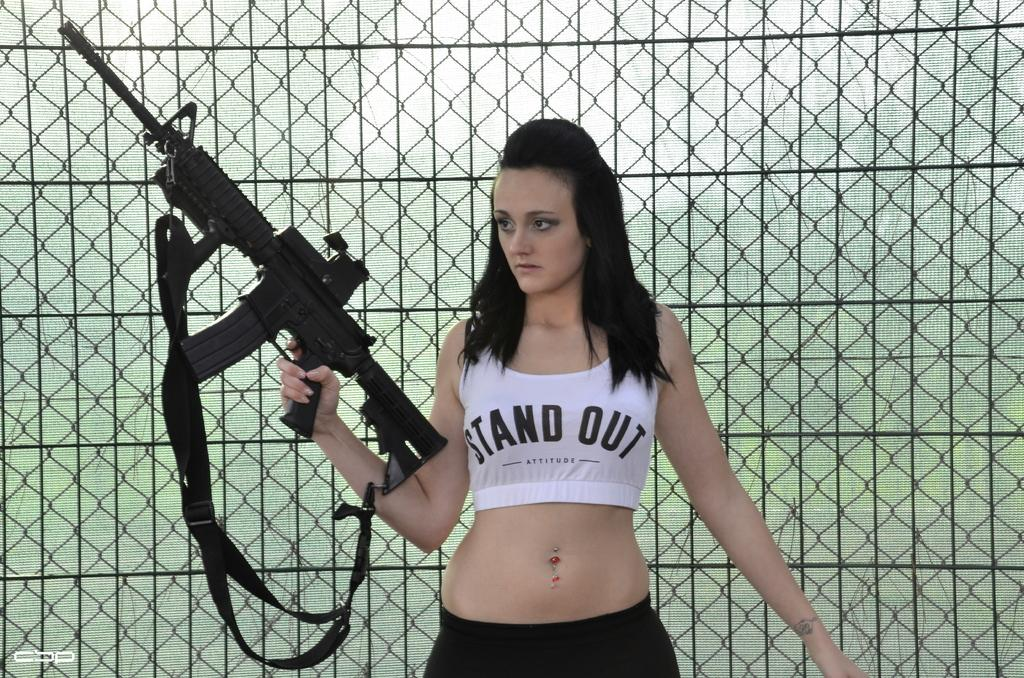Who is the main subject in the image? There is a woman in the center of the image. What is the woman holding in the image? The woman is holding a gun. What can be seen behind the woman in the image? There is fencing behind the woman. What type of cast can be seen on the woman's arm in the image? There is no cast visible on the woman's arm in the image. What adjustments need to be made to the gun in the image? There is no indication in the image that any adjustments need to be made to the gun. 